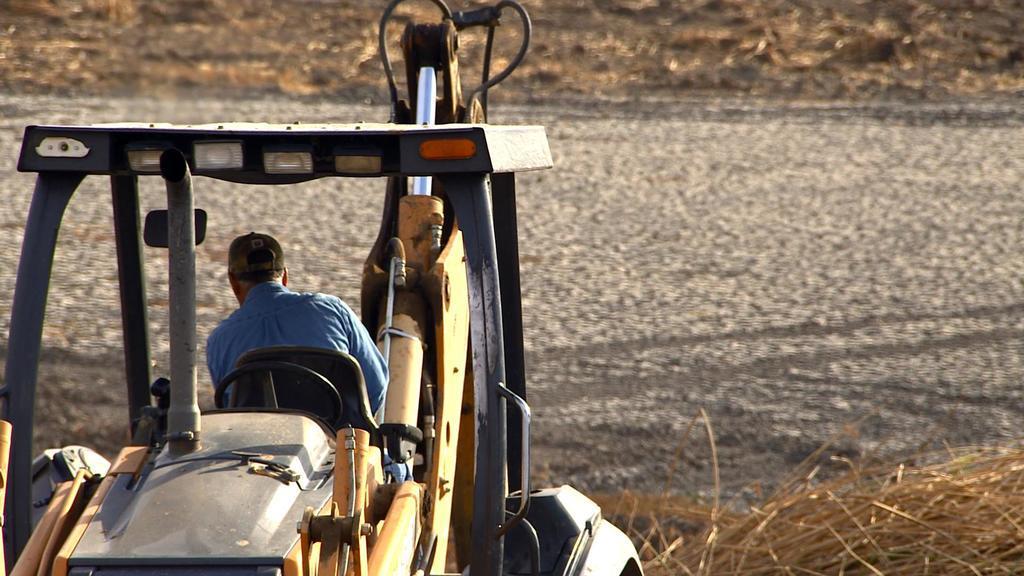In one or two sentences, can you explain what this image depicts? In this image we can see a person is riding a vehicle. He is wearing blue color shirt and cap. Right side of the image dry grass is present. Background of the image land is there. 